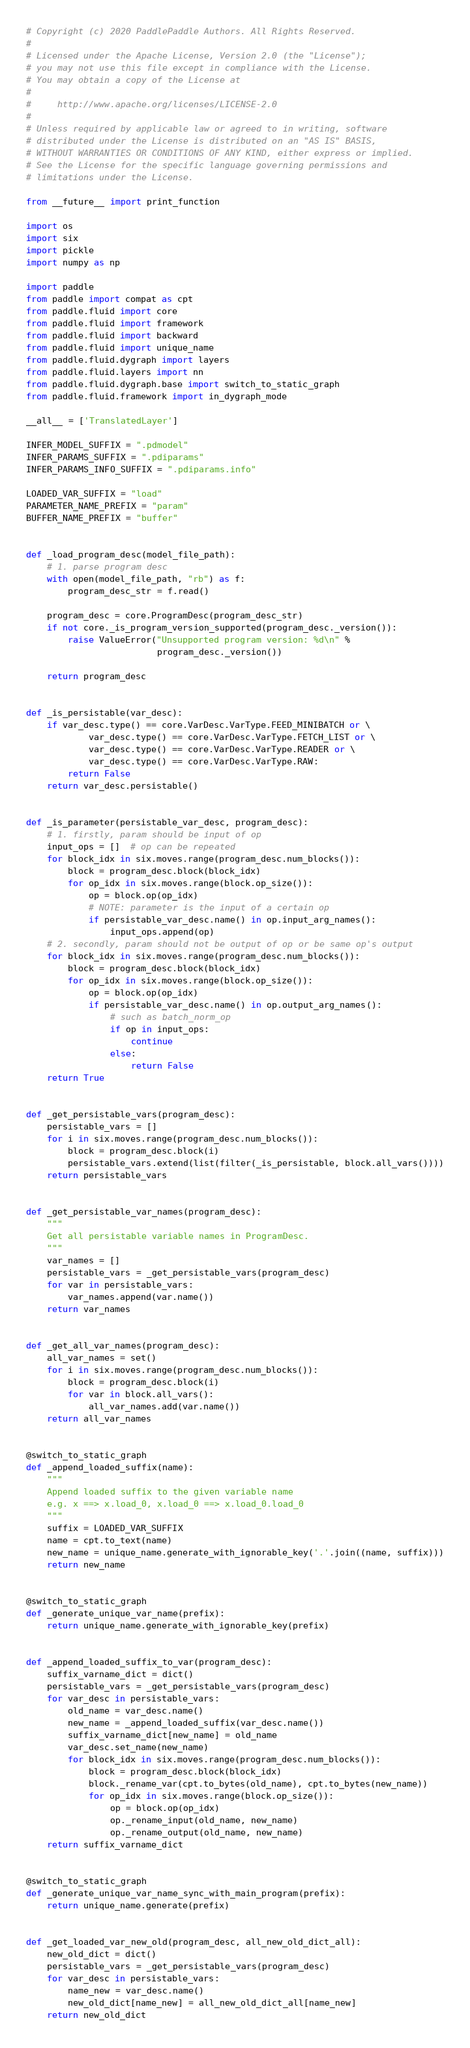<code> <loc_0><loc_0><loc_500><loc_500><_Python_># Copyright (c) 2020 PaddlePaddle Authors. All Rights Reserved.
#
# Licensed under the Apache License, Version 2.0 (the "License");
# you may not use this file except in compliance with the License.
# You may obtain a copy of the License at
#
#     http://www.apache.org/licenses/LICENSE-2.0
#
# Unless required by applicable law or agreed to in writing, software
# distributed under the License is distributed on an "AS IS" BASIS,
# WITHOUT WARRANTIES OR CONDITIONS OF ANY KIND, either express or implied.
# See the License for the specific language governing permissions and
# limitations under the License.

from __future__ import print_function

import os
import six
import pickle
import numpy as np

import paddle
from paddle import compat as cpt
from paddle.fluid import core
from paddle.fluid import framework
from paddle.fluid import backward
from paddle.fluid import unique_name
from paddle.fluid.dygraph import layers
from paddle.fluid.layers import nn
from paddle.fluid.dygraph.base import switch_to_static_graph
from paddle.fluid.framework import in_dygraph_mode

__all__ = ['TranslatedLayer']

INFER_MODEL_SUFFIX = ".pdmodel"
INFER_PARAMS_SUFFIX = ".pdiparams"
INFER_PARAMS_INFO_SUFFIX = ".pdiparams.info"

LOADED_VAR_SUFFIX = "load"
PARAMETER_NAME_PREFIX = "param"
BUFFER_NAME_PREFIX = "buffer"


def _load_program_desc(model_file_path):
    # 1. parse program desc
    with open(model_file_path, "rb") as f:
        program_desc_str = f.read()

    program_desc = core.ProgramDesc(program_desc_str)
    if not core._is_program_version_supported(program_desc._version()):
        raise ValueError("Unsupported program version: %d\n" %
                         program_desc._version())

    return program_desc


def _is_persistable(var_desc):
    if var_desc.type() == core.VarDesc.VarType.FEED_MINIBATCH or \
            var_desc.type() == core.VarDesc.VarType.FETCH_LIST or \
            var_desc.type() == core.VarDesc.VarType.READER or \
            var_desc.type() == core.VarDesc.VarType.RAW:
        return False
    return var_desc.persistable()


def _is_parameter(persistable_var_desc, program_desc):
    # 1. firstly, param should be input of op
    input_ops = []  # op can be repeated
    for block_idx in six.moves.range(program_desc.num_blocks()):
        block = program_desc.block(block_idx)
        for op_idx in six.moves.range(block.op_size()):
            op = block.op(op_idx)
            # NOTE: parameter is the input of a certain op
            if persistable_var_desc.name() in op.input_arg_names():
                input_ops.append(op)
    # 2. secondly, param should not be output of op or be same op's output
    for block_idx in six.moves.range(program_desc.num_blocks()):
        block = program_desc.block(block_idx)
        for op_idx in six.moves.range(block.op_size()):
            op = block.op(op_idx)
            if persistable_var_desc.name() in op.output_arg_names():
                # such as batch_norm_op
                if op in input_ops:
                    continue
                else:
                    return False
    return True


def _get_persistable_vars(program_desc):
    persistable_vars = []
    for i in six.moves.range(program_desc.num_blocks()):
        block = program_desc.block(i)
        persistable_vars.extend(list(filter(_is_persistable, block.all_vars())))
    return persistable_vars


def _get_persistable_var_names(program_desc):
    """
    Get all persistable variable names in ProgramDesc.
    """
    var_names = []
    persistable_vars = _get_persistable_vars(program_desc)
    for var in persistable_vars:
        var_names.append(var.name())
    return var_names


def _get_all_var_names(program_desc):
    all_var_names = set()
    for i in six.moves.range(program_desc.num_blocks()):
        block = program_desc.block(i)
        for var in block.all_vars():
            all_var_names.add(var.name())
    return all_var_names


@switch_to_static_graph
def _append_loaded_suffix(name):
    """
    Append loaded suffix to the given variable name
    e.g. x ==> x.load_0, x.load_0 ==> x.load_0.load_0
    """
    suffix = LOADED_VAR_SUFFIX
    name = cpt.to_text(name)
    new_name = unique_name.generate_with_ignorable_key('.'.join((name, suffix)))
    return new_name


@switch_to_static_graph
def _generate_unique_var_name(prefix):
    return unique_name.generate_with_ignorable_key(prefix)


def _append_loaded_suffix_to_var(program_desc):
    suffix_varname_dict = dict()
    persistable_vars = _get_persistable_vars(program_desc)
    for var_desc in persistable_vars:
        old_name = var_desc.name()
        new_name = _append_loaded_suffix(var_desc.name())
        suffix_varname_dict[new_name] = old_name
        var_desc.set_name(new_name)
        for block_idx in six.moves.range(program_desc.num_blocks()):
            block = program_desc.block(block_idx)
            block._rename_var(cpt.to_bytes(old_name), cpt.to_bytes(new_name))
            for op_idx in six.moves.range(block.op_size()):
                op = block.op(op_idx)
                op._rename_input(old_name, new_name)
                op._rename_output(old_name, new_name)
    return suffix_varname_dict


@switch_to_static_graph
def _generate_unique_var_name_sync_with_main_program(prefix):
    return unique_name.generate(prefix)


def _get_loaded_var_new_old(program_desc, all_new_old_dict_all):
    new_old_dict = dict()
    persistable_vars = _get_persistable_vars(program_desc)
    for var_desc in persistable_vars:
        name_new = var_desc.name()
        new_old_dict[name_new] = all_new_old_dict_all[name_new]
    return new_old_dict

</code> 